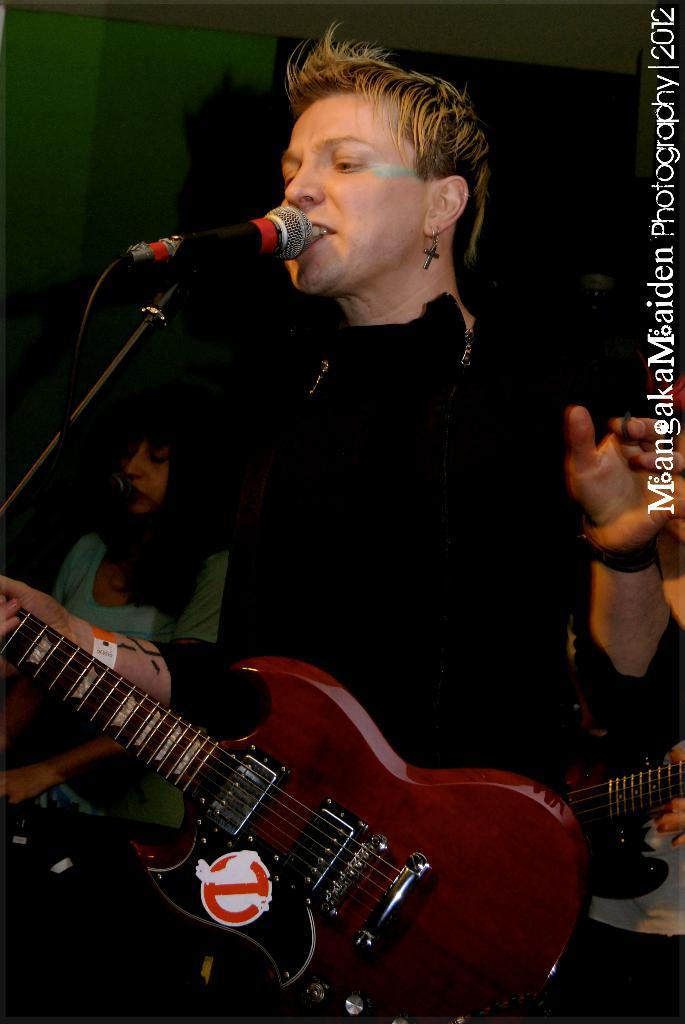What is the person in the image doing? The person is standing and singing a song. What instrument is the person holding? The person is holding a guitar. Can you describe the background of the image? There is another person standing in the background. What equipment is visible in the image for amplifying the person's voice? There is a microphone with a microphone stand in the image. What type of potato is being used as a prop in the image? There is no potato present in the image. Can you describe the fight that is taking place in the image? There is no fight depicted in the image; it features a person singing with a guitar. 